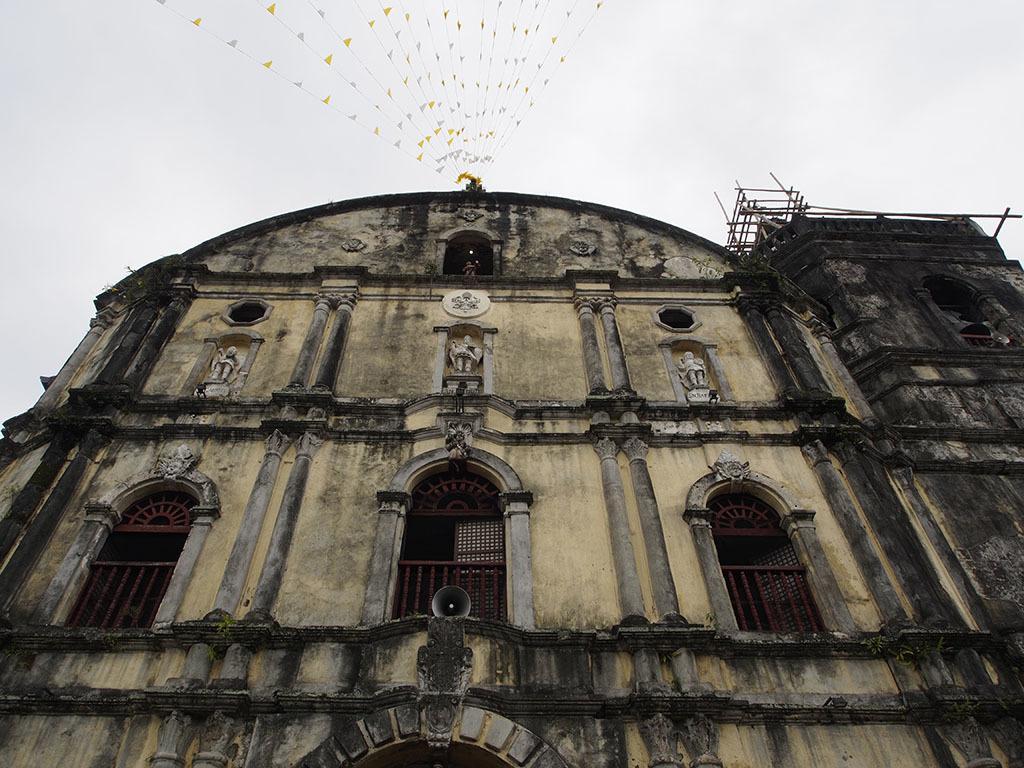Describe this image in one or two sentences. In the picture I can see the building and I can see the small decorative flags bunting at the top of the picture. I can see the statues and pillars. I can see a megaphone and a wooden fence. There are clouds in the sky. 